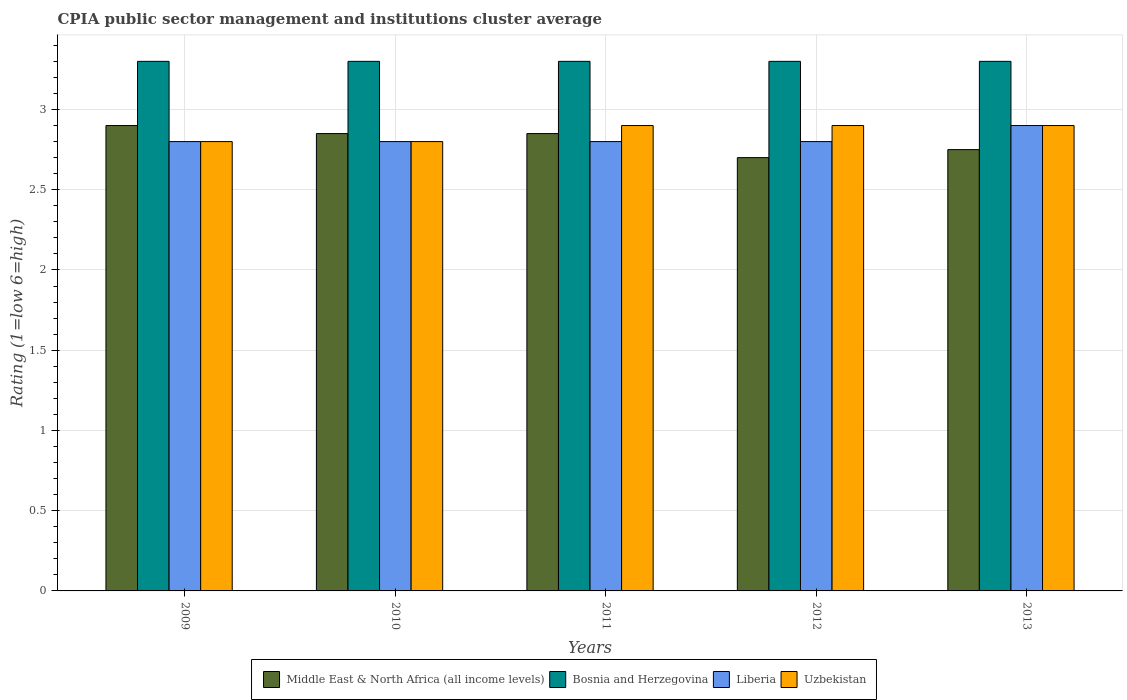Are the number of bars on each tick of the X-axis equal?
Ensure brevity in your answer.  Yes. How many bars are there on the 2nd tick from the left?
Your answer should be compact. 4. How many bars are there on the 2nd tick from the right?
Ensure brevity in your answer.  4. What is the label of the 4th group of bars from the left?
Ensure brevity in your answer.  2012. What is the CPIA rating in Bosnia and Herzegovina in 2010?
Ensure brevity in your answer.  3.3. Across all years, what is the maximum CPIA rating in Uzbekistan?
Your response must be concise. 2.9. Across all years, what is the minimum CPIA rating in Middle East & North Africa (all income levels)?
Provide a short and direct response. 2.7. In which year was the CPIA rating in Middle East & North Africa (all income levels) maximum?
Your response must be concise. 2009. What is the total CPIA rating in Middle East & North Africa (all income levels) in the graph?
Give a very brief answer. 14.05. What is the difference between the CPIA rating in Bosnia and Herzegovina in 2010 and the CPIA rating in Middle East & North Africa (all income levels) in 2009?
Give a very brief answer. 0.4. What is the average CPIA rating in Middle East & North Africa (all income levels) per year?
Ensure brevity in your answer.  2.81. In the year 2013, what is the difference between the CPIA rating in Middle East & North Africa (all income levels) and CPIA rating in Liberia?
Make the answer very short. -0.15. In how many years, is the CPIA rating in Bosnia and Herzegovina greater than 1.6?
Your answer should be very brief. 5. What is the ratio of the CPIA rating in Bosnia and Herzegovina in 2009 to that in 2010?
Give a very brief answer. 1. Is the CPIA rating in Liberia in 2009 less than that in 2010?
Provide a succinct answer. No. What is the difference between the highest and the second highest CPIA rating in Middle East & North Africa (all income levels)?
Keep it short and to the point. 0.05. What is the difference between the highest and the lowest CPIA rating in Uzbekistan?
Make the answer very short. 0.1. Is the sum of the CPIA rating in Liberia in 2009 and 2013 greater than the maximum CPIA rating in Uzbekistan across all years?
Keep it short and to the point. Yes. Is it the case that in every year, the sum of the CPIA rating in Uzbekistan and CPIA rating in Liberia is greater than the sum of CPIA rating in Middle East & North Africa (all income levels) and CPIA rating in Bosnia and Herzegovina?
Ensure brevity in your answer.  No. What does the 1st bar from the left in 2010 represents?
Offer a terse response. Middle East & North Africa (all income levels). What does the 3rd bar from the right in 2012 represents?
Keep it short and to the point. Bosnia and Herzegovina. Is it the case that in every year, the sum of the CPIA rating in Middle East & North Africa (all income levels) and CPIA rating in Bosnia and Herzegovina is greater than the CPIA rating in Uzbekistan?
Offer a very short reply. Yes. Are all the bars in the graph horizontal?
Your answer should be very brief. No. How many years are there in the graph?
Offer a very short reply. 5. What is the difference between two consecutive major ticks on the Y-axis?
Your response must be concise. 0.5. Are the values on the major ticks of Y-axis written in scientific E-notation?
Give a very brief answer. No. Where does the legend appear in the graph?
Your response must be concise. Bottom center. What is the title of the graph?
Make the answer very short. CPIA public sector management and institutions cluster average. Does "Middle East & North Africa (all income levels)" appear as one of the legend labels in the graph?
Offer a very short reply. Yes. What is the label or title of the X-axis?
Give a very brief answer. Years. What is the label or title of the Y-axis?
Offer a very short reply. Rating (1=low 6=high). What is the Rating (1=low 6=high) in Middle East & North Africa (all income levels) in 2009?
Keep it short and to the point. 2.9. What is the Rating (1=low 6=high) of Liberia in 2009?
Keep it short and to the point. 2.8. What is the Rating (1=low 6=high) of Uzbekistan in 2009?
Your answer should be very brief. 2.8. What is the Rating (1=low 6=high) in Middle East & North Africa (all income levels) in 2010?
Offer a terse response. 2.85. What is the Rating (1=low 6=high) in Bosnia and Herzegovina in 2010?
Keep it short and to the point. 3.3. What is the Rating (1=low 6=high) of Liberia in 2010?
Ensure brevity in your answer.  2.8. What is the Rating (1=low 6=high) in Uzbekistan in 2010?
Offer a very short reply. 2.8. What is the Rating (1=low 6=high) in Middle East & North Africa (all income levels) in 2011?
Your answer should be compact. 2.85. What is the Rating (1=low 6=high) in Middle East & North Africa (all income levels) in 2012?
Offer a very short reply. 2.7. What is the Rating (1=low 6=high) of Bosnia and Herzegovina in 2012?
Make the answer very short. 3.3. What is the Rating (1=low 6=high) of Middle East & North Africa (all income levels) in 2013?
Provide a short and direct response. 2.75. Across all years, what is the maximum Rating (1=low 6=high) in Bosnia and Herzegovina?
Your answer should be very brief. 3.3. Across all years, what is the maximum Rating (1=low 6=high) in Liberia?
Your response must be concise. 2.9. Across all years, what is the minimum Rating (1=low 6=high) in Liberia?
Ensure brevity in your answer.  2.8. Across all years, what is the minimum Rating (1=low 6=high) of Uzbekistan?
Your answer should be compact. 2.8. What is the total Rating (1=low 6=high) in Middle East & North Africa (all income levels) in the graph?
Ensure brevity in your answer.  14.05. What is the total Rating (1=low 6=high) in Bosnia and Herzegovina in the graph?
Your answer should be compact. 16.5. What is the difference between the Rating (1=low 6=high) in Bosnia and Herzegovina in 2009 and that in 2010?
Your answer should be compact. 0. What is the difference between the Rating (1=low 6=high) in Uzbekistan in 2009 and that in 2010?
Provide a short and direct response. 0. What is the difference between the Rating (1=low 6=high) in Liberia in 2009 and that in 2011?
Ensure brevity in your answer.  0. What is the difference between the Rating (1=low 6=high) in Uzbekistan in 2009 and that in 2011?
Keep it short and to the point. -0.1. What is the difference between the Rating (1=low 6=high) in Middle East & North Africa (all income levels) in 2009 and that in 2012?
Your answer should be compact. 0.2. What is the difference between the Rating (1=low 6=high) in Bosnia and Herzegovina in 2009 and that in 2012?
Your answer should be compact. 0. What is the difference between the Rating (1=low 6=high) in Liberia in 2009 and that in 2012?
Your response must be concise. 0. What is the difference between the Rating (1=low 6=high) in Liberia in 2009 and that in 2013?
Make the answer very short. -0.1. What is the difference between the Rating (1=low 6=high) in Uzbekistan in 2009 and that in 2013?
Your answer should be very brief. -0.1. What is the difference between the Rating (1=low 6=high) in Middle East & North Africa (all income levels) in 2010 and that in 2011?
Your answer should be very brief. 0. What is the difference between the Rating (1=low 6=high) of Bosnia and Herzegovina in 2010 and that in 2011?
Offer a very short reply. 0. What is the difference between the Rating (1=low 6=high) in Liberia in 2010 and that in 2011?
Your response must be concise. 0. What is the difference between the Rating (1=low 6=high) in Middle East & North Africa (all income levels) in 2010 and that in 2012?
Offer a very short reply. 0.15. What is the difference between the Rating (1=low 6=high) of Bosnia and Herzegovina in 2010 and that in 2012?
Keep it short and to the point. 0. What is the difference between the Rating (1=low 6=high) of Liberia in 2010 and that in 2013?
Provide a succinct answer. -0.1. What is the difference between the Rating (1=low 6=high) of Uzbekistan in 2011 and that in 2012?
Provide a succinct answer. 0. What is the difference between the Rating (1=low 6=high) in Middle East & North Africa (all income levels) in 2011 and that in 2013?
Make the answer very short. 0.1. What is the difference between the Rating (1=low 6=high) of Bosnia and Herzegovina in 2011 and that in 2013?
Your answer should be very brief. 0. What is the difference between the Rating (1=low 6=high) in Liberia in 2011 and that in 2013?
Ensure brevity in your answer.  -0.1. What is the difference between the Rating (1=low 6=high) in Middle East & North Africa (all income levels) in 2012 and that in 2013?
Make the answer very short. -0.05. What is the difference between the Rating (1=low 6=high) of Bosnia and Herzegovina in 2012 and that in 2013?
Offer a terse response. 0. What is the difference between the Rating (1=low 6=high) of Uzbekistan in 2012 and that in 2013?
Your answer should be very brief. 0. What is the difference between the Rating (1=low 6=high) in Middle East & North Africa (all income levels) in 2009 and the Rating (1=low 6=high) in Bosnia and Herzegovina in 2010?
Your answer should be very brief. -0.4. What is the difference between the Rating (1=low 6=high) of Middle East & North Africa (all income levels) in 2009 and the Rating (1=low 6=high) of Liberia in 2010?
Ensure brevity in your answer.  0.1. What is the difference between the Rating (1=low 6=high) of Middle East & North Africa (all income levels) in 2009 and the Rating (1=low 6=high) of Uzbekistan in 2010?
Provide a succinct answer. 0.1. What is the difference between the Rating (1=low 6=high) in Bosnia and Herzegovina in 2009 and the Rating (1=low 6=high) in Liberia in 2011?
Offer a terse response. 0.5. What is the difference between the Rating (1=low 6=high) of Bosnia and Herzegovina in 2009 and the Rating (1=low 6=high) of Uzbekistan in 2011?
Offer a very short reply. 0.4. What is the difference between the Rating (1=low 6=high) in Middle East & North Africa (all income levels) in 2009 and the Rating (1=low 6=high) in Bosnia and Herzegovina in 2012?
Keep it short and to the point. -0.4. What is the difference between the Rating (1=low 6=high) of Middle East & North Africa (all income levels) in 2009 and the Rating (1=low 6=high) of Uzbekistan in 2012?
Provide a succinct answer. 0. What is the difference between the Rating (1=low 6=high) of Middle East & North Africa (all income levels) in 2009 and the Rating (1=low 6=high) of Bosnia and Herzegovina in 2013?
Give a very brief answer. -0.4. What is the difference between the Rating (1=low 6=high) of Bosnia and Herzegovina in 2009 and the Rating (1=low 6=high) of Liberia in 2013?
Give a very brief answer. 0.4. What is the difference between the Rating (1=low 6=high) of Liberia in 2009 and the Rating (1=low 6=high) of Uzbekistan in 2013?
Keep it short and to the point. -0.1. What is the difference between the Rating (1=low 6=high) of Middle East & North Africa (all income levels) in 2010 and the Rating (1=low 6=high) of Bosnia and Herzegovina in 2011?
Give a very brief answer. -0.45. What is the difference between the Rating (1=low 6=high) in Middle East & North Africa (all income levels) in 2010 and the Rating (1=low 6=high) in Liberia in 2011?
Make the answer very short. 0.05. What is the difference between the Rating (1=low 6=high) in Middle East & North Africa (all income levels) in 2010 and the Rating (1=low 6=high) in Uzbekistan in 2011?
Keep it short and to the point. -0.05. What is the difference between the Rating (1=low 6=high) in Bosnia and Herzegovina in 2010 and the Rating (1=low 6=high) in Uzbekistan in 2011?
Keep it short and to the point. 0.4. What is the difference between the Rating (1=low 6=high) in Liberia in 2010 and the Rating (1=low 6=high) in Uzbekistan in 2011?
Offer a terse response. -0.1. What is the difference between the Rating (1=low 6=high) of Middle East & North Africa (all income levels) in 2010 and the Rating (1=low 6=high) of Bosnia and Herzegovina in 2012?
Your answer should be compact. -0.45. What is the difference between the Rating (1=low 6=high) in Middle East & North Africa (all income levels) in 2010 and the Rating (1=low 6=high) in Liberia in 2012?
Your response must be concise. 0.05. What is the difference between the Rating (1=low 6=high) of Middle East & North Africa (all income levels) in 2010 and the Rating (1=low 6=high) of Bosnia and Herzegovina in 2013?
Your response must be concise. -0.45. What is the difference between the Rating (1=low 6=high) in Bosnia and Herzegovina in 2010 and the Rating (1=low 6=high) in Liberia in 2013?
Your response must be concise. 0.4. What is the difference between the Rating (1=low 6=high) of Liberia in 2010 and the Rating (1=low 6=high) of Uzbekistan in 2013?
Your response must be concise. -0.1. What is the difference between the Rating (1=low 6=high) in Middle East & North Africa (all income levels) in 2011 and the Rating (1=low 6=high) in Bosnia and Herzegovina in 2012?
Make the answer very short. -0.45. What is the difference between the Rating (1=low 6=high) in Middle East & North Africa (all income levels) in 2011 and the Rating (1=low 6=high) in Liberia in 2012?
Offer a terse response. 0.05. What is the difference between the Rating (1=low 6=high) of Middle East & North Africa (all income levels) in 2011 and the Rating (1=low 6=high) of Uzbekistan in 2012?
Your answer should be very brief. -0.05. What is the difference between the Rating (1=low 6=high) of Bosnia and Herzegovina in 2011 and the Rating (1=low 6=high) of Liberia in 2012?
Give a very brief answer. 0.5. What is the difference between the Rating (1=low 6=high) in Liberia in 2011 and the Rating (1=low 6=high) in Uzbekistan in 2012?
Your answer should be compact. -0.1. What is the difference between the Rating (1=low 6=high) in Middle East & North Africa (all income levels) in 2011 and the Rating (1=low 6=high) in Bosnia and Herzegovina in 2013?
Ensure brevity in your answer.  -0.45. What is the difference between the Rating (1=low 6=high) of Middle East & North Africa (all income levels) in 2011 and the Rating (1=low 6=high) of Liberia in 2013?
Your answer should be compact. -0.05. What is the difference between the Rating (1=low 6=high) of Middle East & North Africa (all income levels) in 2012 and the Rating (1=low 6=high) of Bosnia and Herzegovina in 2013?
Give a very brief answer. -0.6. What is the difference between the Rating (1=low 6=high) of Middle East & North Africa (all income levels) in 2012 and the Rating (1=low 6=high) of Liberia in 2013?
Your response must be concise. -0.2. What is the difference between the Rating (1=low 6=high) in Bosnia and Herzegovina in 2012 and the Rating (1=low 6=high) in Uzbekistan in 2013?
Make the answer very short. 0.4. What is the difference between the Rating (1=low 6=high) in Liberia in 2012 and the Rating (1=low 6=high) in Uzbekistan in 2013?
Your response must be concise. -0.1. What is the average Rating (1=low 6=high) in Middle East & North Africa (all income levels) per year?
Provide a short and direct response. 2.81. What is the average Rating (1=low 6=high) in Liberia per year?
Give a very brief answer. 2.82. What is the average Rating (1=low 6=high) of Uzbekistan per year?
Your answer should be very brief. 2.86. In the year 2009, what is the difference between the Rating (1=low 6=high) in Middle East & North Africa (all income levels) and Rating (1=low 6=high) in Liberia?
Give a very brief answer. 0.1. In the year 2009, what is the difference between the Rating (1=low 6=high) in Bosnia and Herzegovina and Rating (1=low 6=high) in Liberia?
Offer a terse response. 0.5. In the year 2010, what is the difference between the Rating (1=low 6=high) in Middle East & North Africa (all income levels) and Rating (1=low 6=high) in Bosnia and Herzegovina?
Your answer should be compact. -0.45. In the year 2010, what is the difference between the Rating (1=low 6=high) of Middle East & North Africa (all income levels) and Rating (1=low 6=high) of Liberia?
Make the answer very short. 0.05. In the year 2010, what is the difference between the Rating (1=low 6=high) of Middle East & North Africa (all income levels) and Rating (1=low 6=high) of Uzbekistan?
Offer a terse response. 0.05. In the year 2010, what is the difference between the Rating (1=low 6=high) of Bosnia and Herzegovina and Rating (1=low 6=high) of Uzbekistan?
Offer a very short reply. 0.5. In the year 2011, what is the difference between the Rating (1=low 6=high) in Middle East & North Africa (all income levels) and Rating (1=low 6=high) in Bosnia and Herzegovina?
Your answer should be very brief. -0.45. In the year 2011, what is the difference between the Rating (1=low 6=high) of Middle East & North Africa (all income levels) and Rating (1=low 6=high) of Liberia?
Keep it short and to the point. 0.05. In the year 2011, what is the difference between the Rating (1=low 6=high) of Middle East & North Africa (all income levels) and Rating (1=low 6=high) of Uzbekistan?
Offer a terse response. -0.05. In the year 2011, what is the difference between the Rating (1=low 6=high) in Bosnia and Herzegovina and Rating (1=low 6=high) in Liberia?
Give a very brief answer. 0.5. In the year 2011, what is the difference between the Rating (1=low 6=high) of Liberia and Rating (1=low 6=high) of Uzbekistan?
Provide a succinct answer. -0.1. In the year 2012, what is the difference between the Rating (1=low 6=high) of Middle East & North Africa (all income levels) and Rating (1=low 6=high) of Liberia?
Make the answer very short. -0.1. In the year 2012, what is the difference between the Rating (1=low 6=high) of Bosnia and Herzegovina and Rating (1=low 6=high) of Liberia?
Give a very brief answer. 0.5. In the year 2012, what is the difference between the Rating (1=low 6=high) of Liberia and Rating (1=low 6=high) of Uzbekistan?
Give a very brief answer. -0.1. In the year 2013, what is the difference between the Rating (1=low 6=high) of Middle East & North Africa (all income levels) and Rating (1=low 6=high) of Bosnia and Herzegovina?
Offer a very short reply. -0.55. In the year 2013, what is the difference between the Rating (1=low 6=high) of Middle East & North Africa (all income levels) and Rating (1=low 6=high) of Liberia?
Your answer should be compact. -0.15. In the year 2013, what is the difference between the Rating (1=low 6=high) in Bosnia and Herzegovina and Rating (1=low 6=high) in Uzbekistan?
Provide a short and direct response. 0.4. In the year 2013, what is the difference between the Rating (1=low 6=high) of Liberia and Rating (1=low 6=high) of Uzbekistan?
Your answer should be very brief. 0. What is the ratio of the Rating (1=low 6=high) in Middle East & North Africa (all income levels) in 2009 to that in 2010?
Your response must be concise. 1.02. What is the ratio of the Rating (1=low 6=high) in Liberia in 2009 to that in 2010?
Your response must be concise. 1. What is the ratio of the Rating (1=low 6=high) in Middle East & North Africa (all income levels) in 2009 to that in 2011?
Make the answer very short. 1.02. What is the ratio of the Rating (1=low 6=high) in Uzbekistan in 2009 to that in 2011?
Provide a short and direct response. 0.97. What is the ratio of the Rating (1=low 6=high) of Middle East & North Africa (all income levels) in 2009 to that in 2012?
Your answer should be very brief. 1.07. What is the ratio of the Rating (1=low 6=high) in Bosnia and Herzegovina in 2009 to that in 2012?
Your answer should be very brief. 1. What is the ratio of the Rating (1=low 6=high) of Liberia in 2009 to that in 2012?
Your response must be concise. 1. What is the ratio of the Rating (1=low 6=high) in Uzbekistan in 2009 to that in 2012?
Your answer should be very brief. 0.97. What is the ratio of the Rating (1=low 6=high) of Middle East & North Africa (all income levels) in 2009 to that in 2013?
Give a very brief answer. 1.05. What is the ratio of the Rating (1=low 6=high) in Bosnia and Herzegovina in 2009 to that in 2013?
Provide a short and direct response. 1. What is the ratio of the Rating (1=low 6=high) of Liberia in 2009 to that in 2013?
Ensure brevity in your answer.  0.97. What is the ratio of the Rating (1=low 6=high) of Uzbekistan in 2009 to that in 2013?
Keep it short and to the point. 0.97. What is the ratio of the Rating (1=low 6=high) in Liberia in 2010 to that in 2011?
Provide a short and direct response. 1. What is the ratio of the Rating (1=low 6=high) of Uzbekistan in 2010 to that in 2011?
Give a very brief answer. 0.97. What is the ratio of the Rating (1=low 6=high) of Middle East & North Africa (all income levels) in 2010 to that in 2012?
Offer a terse response. 1.06. What is the ratio of the Rating (1=low 6=high) in Bosnia and Herzegovina in 2010 to that in 2012?
Offer a terse response. 1. What is the ratio of the Rating (1=low 6=high) of Liberia in 2010 to that in 2012?
Your answer should be compact. 1. What is the ratio of the Rating (1=low 6=high) in Uzbekistan in 2010 to that in 2012?
Your response must be concise. 0.97. What is the ratio of the Rating (1=low 6=high) in Middle East & North Africa (all income levels) in 2010 to that in 2013?
Make the answer very short. 1.04. What is the ratio of the Rating (1=low 6=high) of Bosnia and Herzegovina in 2010 to that in 2013?
Offer a terse response. 1. What is the ratio of the Rating (1=low 6=high) in Liberia in 2010 to that in 2013?
Your answer should be compact. 0.97. What is the ratio of the Rating (1=low 6=high) of Uzbekistan in 2010 to that in 2013?
Keep it short and to the point. 0.97. What is the ratio of the Rating (1=low 6=high) of Middle East & North Africa (all income levels) in 2011 to that in 2012?
Give a very brief answer. 1.06. What is the ratio of the Rating (1=low 6=high) of Bosnia and Herzegovina in 2011 to that in 2012?
Offer a terse response. 1. What is the ratio of the Rating (1=low 6=high) of Liberia in 2011 to that in 2012?
Offer a very short reply. 1. What is the ratio of the Rating (1=low 6=high) in Middle East & North Africa (all income levels) in 2011 to that in 2013?
Keep it short and to the point. 1.04. What is the ratio of the Rating (1=low 6=high) in Bosnia and Herzegovina in 2011 to that in 2013?
Your response must be concise. 1. What is the ratio of the Rating (1=low 6=high) in Liberia in 2011 to that in 2013?
Ensure brevity in your answer.  0.97. What is the ratio of the Rating (1=low 6=high) of Uzbekistan in 2011 to that in 2013?
Offer a very short reply. 1. What is the ratio of the Rating (1=low 6=high) of Middle East & North Africa (all income levels) in 2012 to that in 2013?
Provide a succinct answer. 0.98. What is the ratio of the Rating (1=low 6=high) in Bosnia and Herzegovina in 2012 to that in 2013?
Offer a terse response. 1. What is the ratio of the Rating (1=low 6=high) in Liberia in 2012 to that in 2013?
Provide a succinct answer. 0.97. What is the ratio of the Rating (1=low 6=high) in Uzbekistan in 2012 to that in 2013?
Offer a very short reply. 1. What is the difference between the highest and the second highest Rating (1=low 6=high) of Middle East & North Africa (all income levels)?
Provide a short and direct response. 0.05. What is the difference between the highest and the second highest Rating (1=low 6=high) of Liberia?
Offer a very short reply. 0.1. What is the difference between the highest and the second highest Rating (1=low 6=high) in Uzbekistan?
Ensure brevity in your answer.  0. What is the difference between the highest and the lowest Rating (1=low 6=high) in Middle East & North Africa (all income levels)?
Offer a terse response. 0.2. What is the difference between the highest and the lowest Rating (1=low 6=high) of Uzbekistan?
Your answer should be compact. 0.1. 